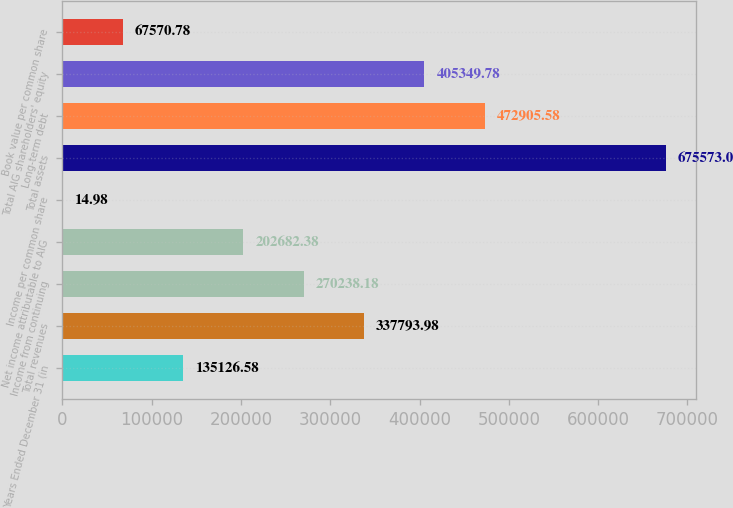Convert chart. <chart><loc_0><loc_0><loc_500><loc_500><bar_chart><fcel>Years Ended December 31 (in<fcel>Total revenues<fcel>Income from continuing<fcel>Net income attributable to AIG<fcel>Income per common share<fcel>Total assets<fcel>Long-term debt<fcel>Total AIG shareholders' equity<fcel>Book value per common share<nl><fcel>135127<fcel>337794<fcel>270238<fcel>202682<fcel>14.98<fcel>675573<fcel>472906<fcel>405350<fcel>67570.8<nl></chart> 